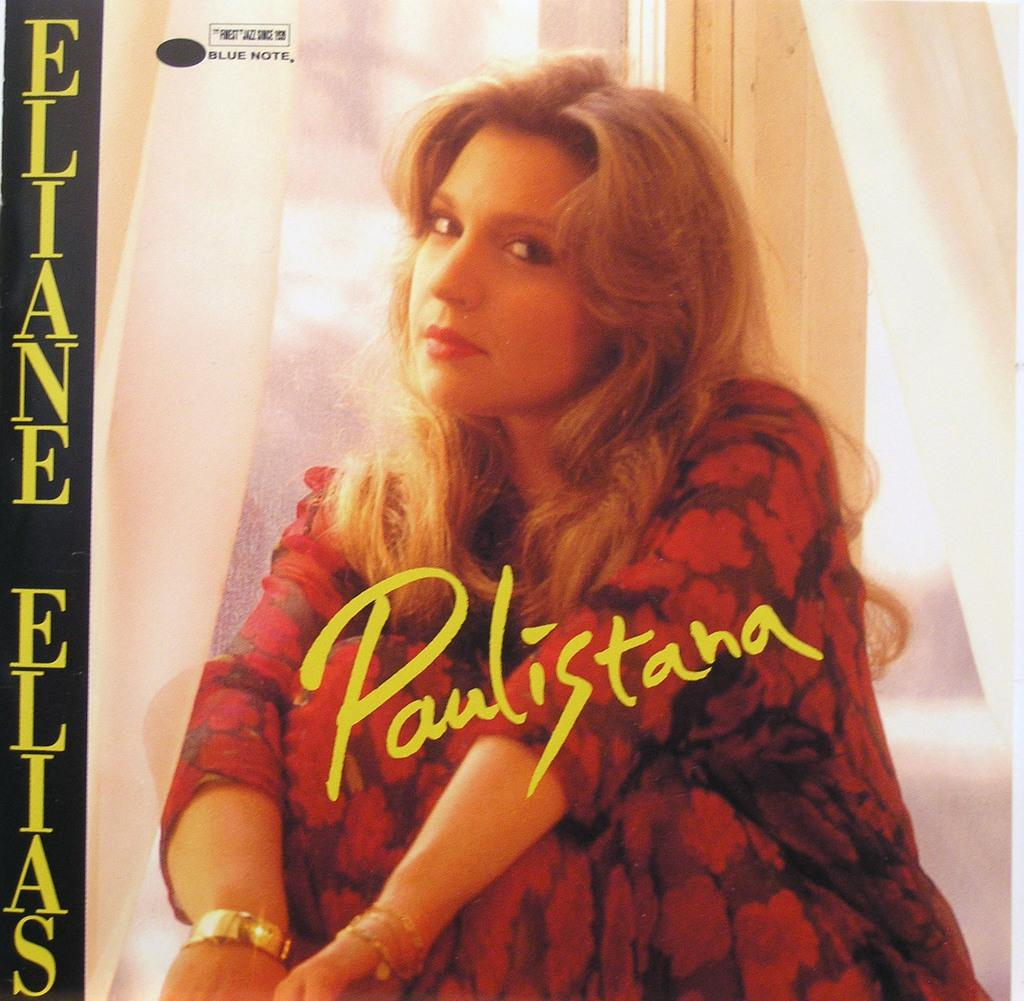What is the main subject in the center of the image? There is a woman sitting in the center of the image. What else can be seen in the image besides the woman? There is some text in the center and on the left side of the image. What is visible in the background of the image? There is a window in the background of the image. Are there any window treatments present in the image? Yes, there are curtains associated with the window. What type of noise can be heard coming from the frame in the image? There is no frame present in the image, and therefore no noise can be heard from it. 